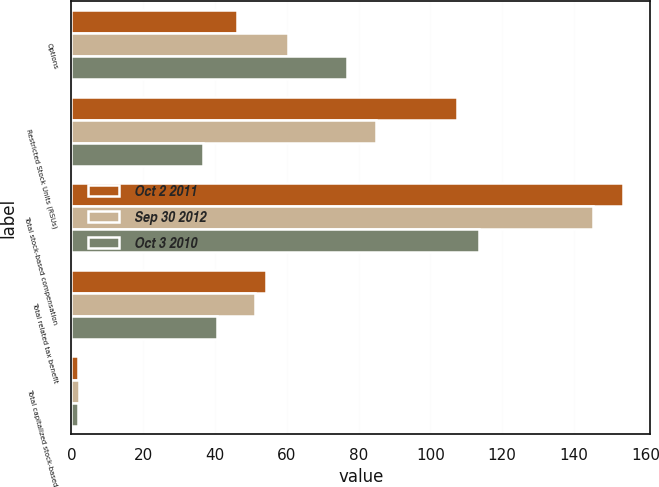Convert chart to OTSL. <chart><loc_0><loc_0><loc_500><loc_500><stacked_bar_chart><ecel><fcel>Options<fcel>Restricted Stock Units (RSUs)<fcel>Total stock-based compensation<fcel>Total related tax benefit<fcel>Total capitalized stock-based<nl><fcel>Oct 2 2011<fcel>46.2<fcel>107.4<fcel>153.6<fcel>54.2<fcel>2<nl><fcel>Sep 30 2012<fcel>60.4<fcel>84.8<fcel>145.2<fcel>51.2<fcel>2.1<nl><fcel>Oct 3 2010<fcel>76.8<fcel>36.8<fcel>113.6<fcel>40.6<fcel>1.9<nl></chart> 